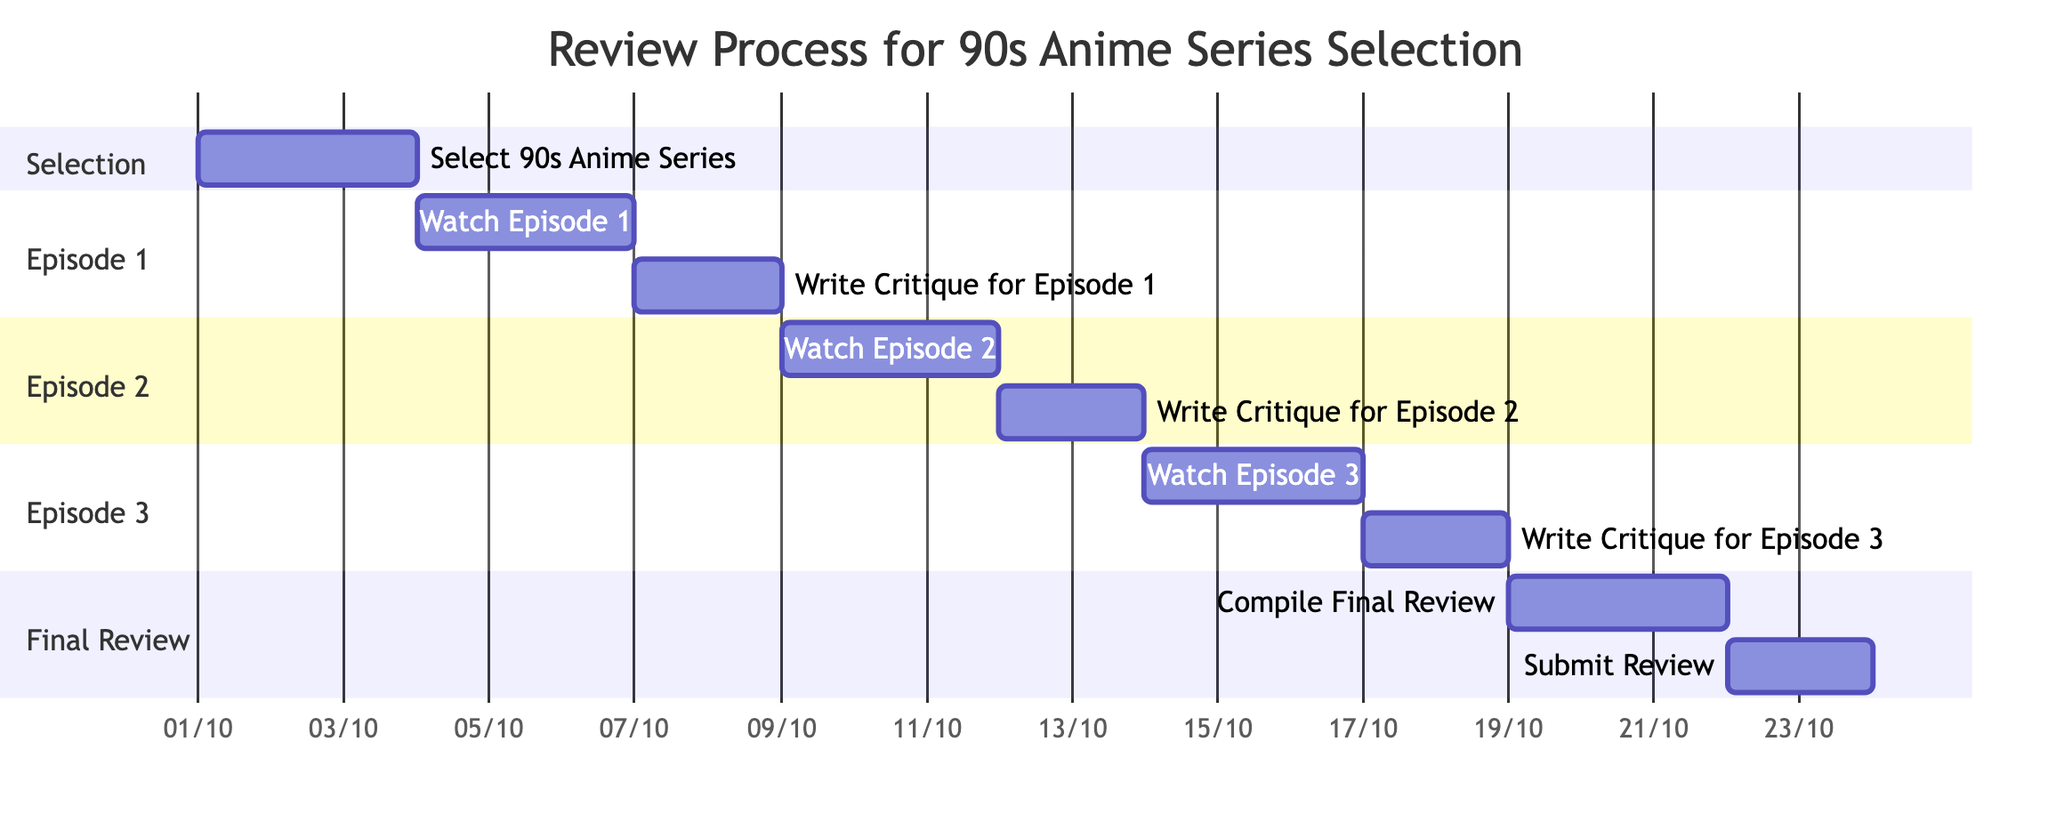What is the duration for watching Episode 1? The Gantt chart indicates the task "Watch Episode 1" has a duration of 3 days.
Answer: 3 days What comes after writing the critique for Episode 2? According to the chart, after completing "Write Critique for Episode 2," the next task is "Watch Episode 3."
Answer: Watch Episode 3 How many total tasks are there in the diagram? By counting the tasks listed in each section of the Gantt chart, there are 9 total tasks.
Answer: 9 What is the end date for compiling the final review? The task "Compile Final Review" ends on October 21, 2023, as shown in the end date section of the Gantt chart.
Answer: 2023-10-21 How long in total will it take to review all three episodes? Summing the durations for watching all episodes and writing critiques results in a total of 15 days (3 days for each episode and 2 days for each critique).
Answer: 15 days What is the start date for the selection of the 90s anime series? The chart shows that the task "Select 90s Anime Series" starts on October 1, 2023.
Answer: 2023-10-01 Which task has the latest start date? Analyzing the start dates, the task "Submit Review" begins on October 22, 2023, making it the latest start date in the diagram.
Answer: Submit Review How many days after watching Episode 3 does the final review get compiled? The "Compile Final Review" task starts immediately after "Write Critique for Episode 3," which is a total of 3 days after that task ends (taking into account the 2 days for writing the critique).
Answer: 3 days What section immediately follows the selection process? The section "Episode 1" follows directly after the "Selection" section in the Gantt chart layout.
Answer: Episode 1 